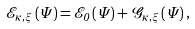Convert formula to latex. <formula><loc_0><loc_0><loc_500><loc_500>\mathcal { E } _ { \kappa , \xi } \left ( \Psi \right ) = \mathcal { E } _ { 0 } \left ( \Psi \right ) + \mathcal { G } _ { \kappa , \xi } \left ( \Psi \right ) ,</formula> 